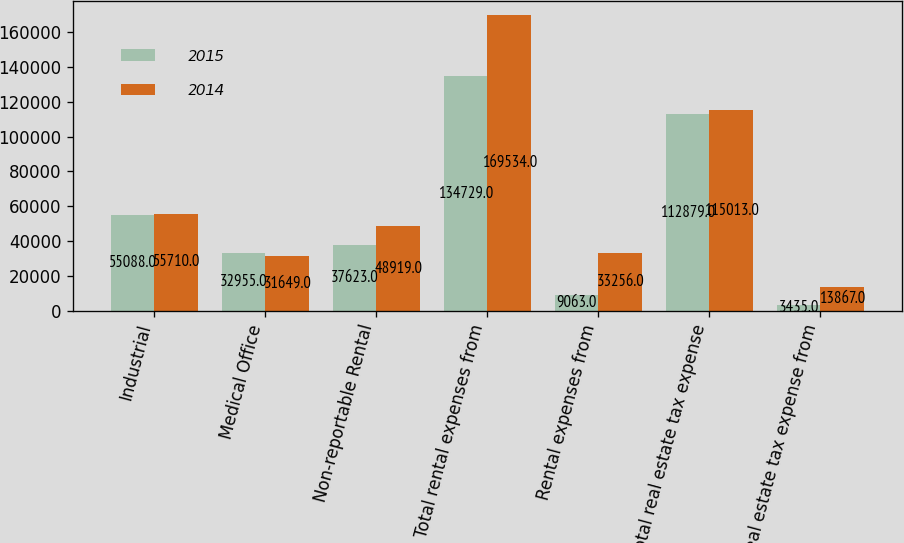Convert chart. <chart><loc_0><loc_0><loc_500><loc_500><stacked_bar_chart><ecel><fcel>Industrial<fcel>Medical Office<fcel>Non-reportable Rental<fcel>Total rental expenses from<fcel>Rental expenses from<fcel>Total real estate tax expense<fcel>Real estate tax expense from<nl><fcel>2015<fcel>55088<fcel>32955<fcel>37623<fcel>134729<fcel>9063<fcel>112879<fcel>3435<nl><fcel>2014<fcel>55710<fcel>31649<fcel>48919<fcel>169534<fcel>33256<fcel>115013<fcel>13867<nl></chart> 